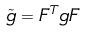<formula> <loc_0><loc_0><loc_500><loc_500>\tilde { g } = F ^ { T } g F</formula> 